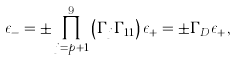<formula> <loc_0><loc_0><loc_500><loc_500>\epsilon _ { - } = \pm \prod _ { j = p + 1 } ^ { 9 } \left ( \Gamma _ { j } \Gamma _ { 1 1 } \right ) \epsilon _ { + } = \pm \Gamma _ { D } \epsilon _ { + } ,</formula> 